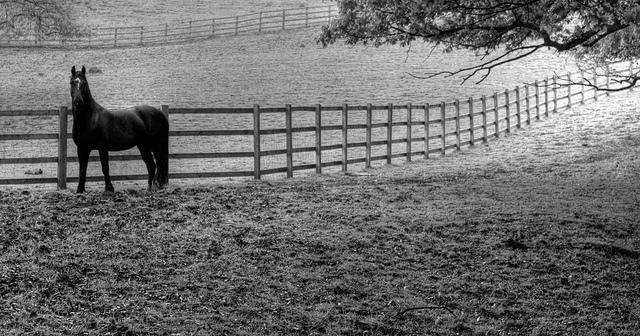How many horses are there?
Give a very brief answer. 1. 